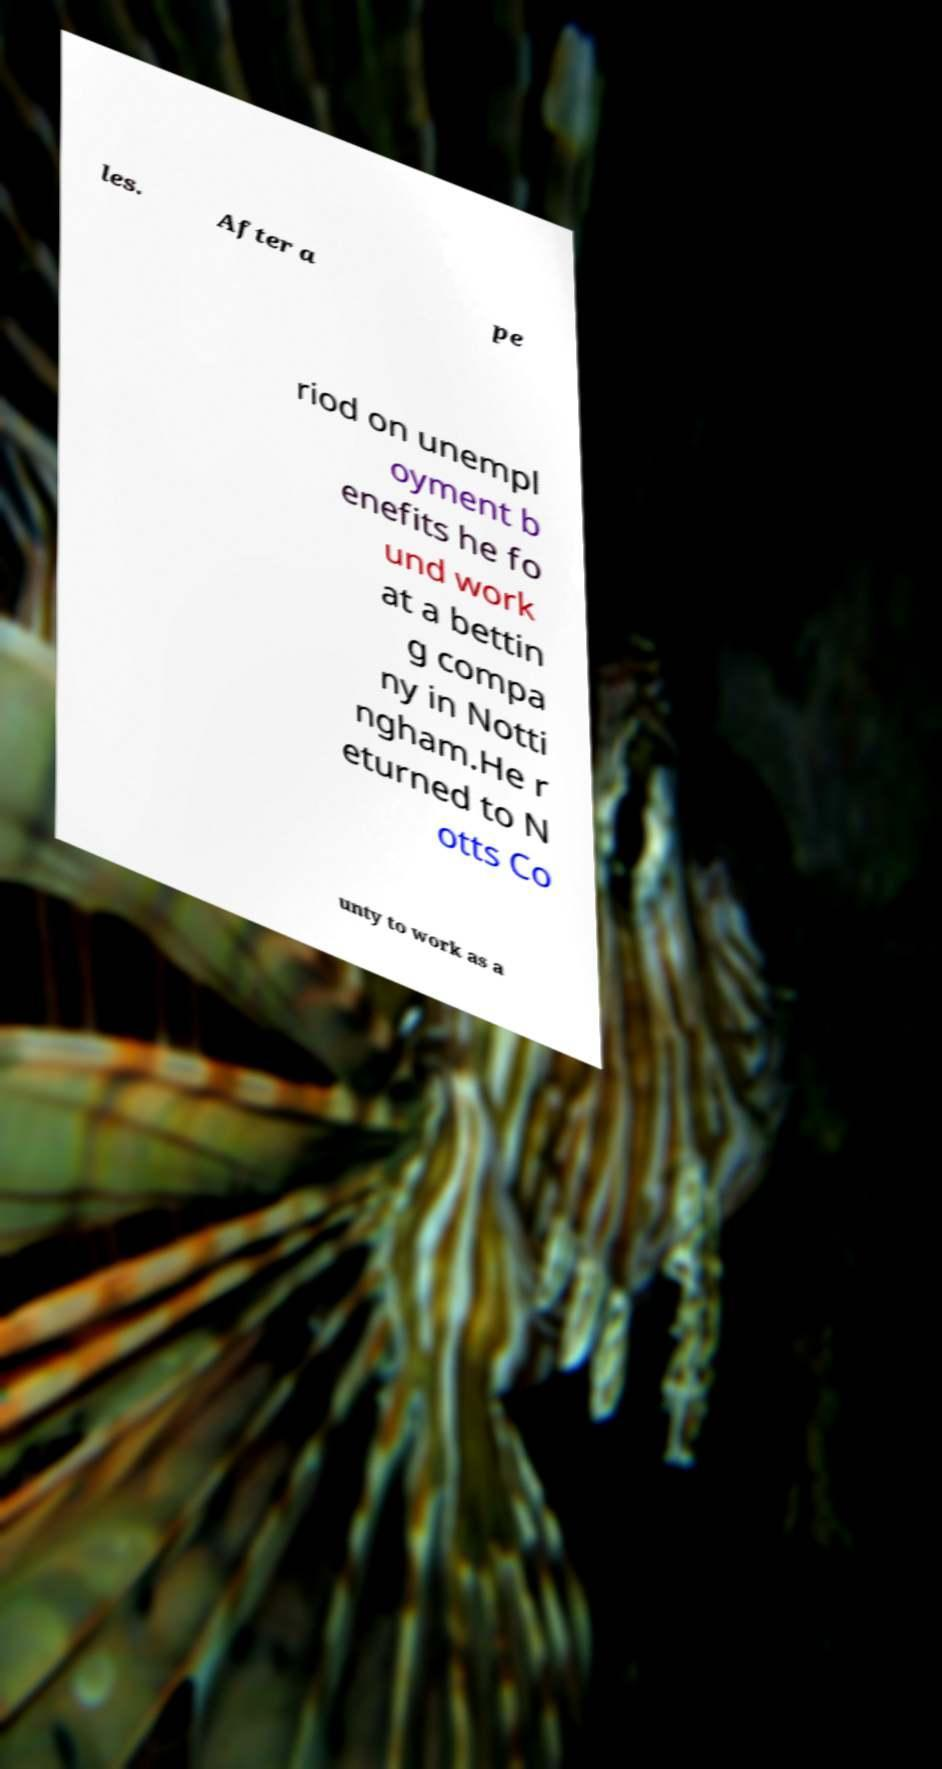Could you extract and type out the text from this image? les. After a pe riod on unempl oyment b enefits he fo und work at a bettin g compa ny in Notti ngham.He r eturned to N otts Co unty to work as a 